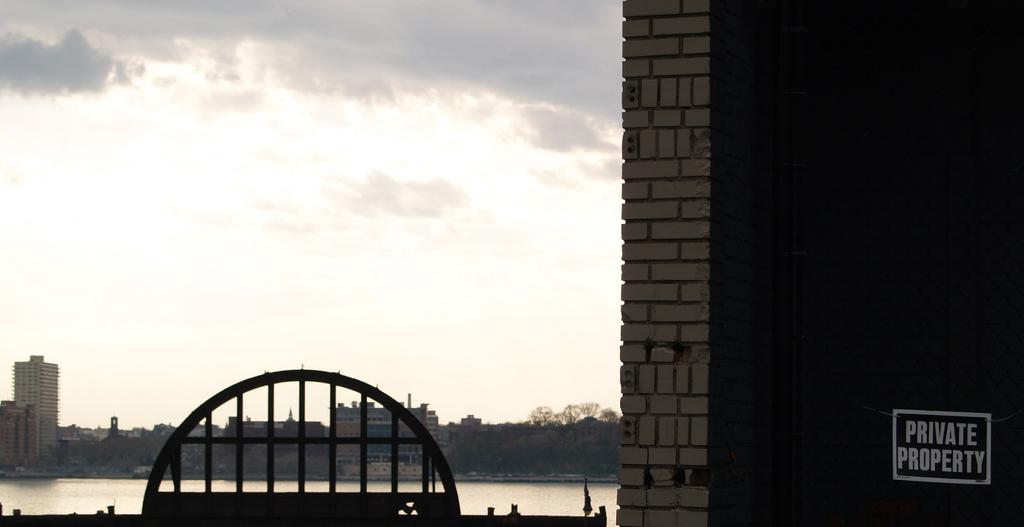What does the property sign say?
Provide a short and direct response. Private property. 